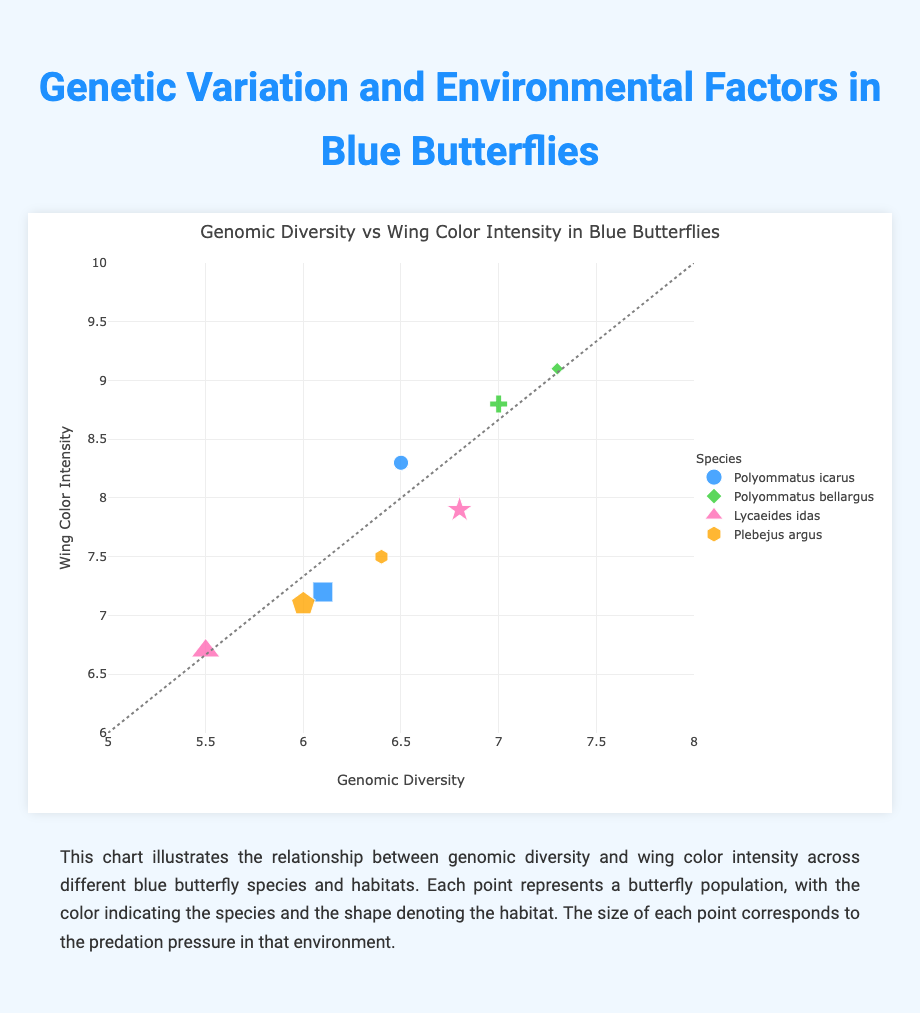What is the title of the chart? The title is located at the top of the chart and indicates what the data is about.
Answer: Genomic Diversity vs Wing Color Intensity in Blue Butterflies How many species of blue butterflies are represented in the chart? The legend on the right side of the chart lists the different species, each represented by a different color.
Answer: Four Which species shows the highest wing color intensity? By observing the y-axis (Wing Color Intensity) and correlating it with the species, the highest point corresponds to "Polyommatus bellargus".
Answer: Polyommatus bellargus Which habitat has a butterfly with the lowest genomic diversity? Check the x-axis (Genomic Diversity) to find the smallest value and then refer to the hover text or symbols to identify the corresponding habitat.
Answer: Boreal Forest Which species experiences the highest predation pressure? Look for the largest markers, as predation pressure is represented by the size of the points. The species' details can be verified by the legend.
Answer: Lycaeides idas What is the average wing color intensity of "Plebejus argus" butterflies? Find all points associated with "Plebejus argus", note their y-values (wing color intensity), sum them up, and divide by the number of points. The values are 7.5 and 7.1, so (7.5 + 7.1) / 2 = 7.3.
Answer: 7.3 Which habitat tends to have butterflies with higher genomic diversity: Grassland or Coastal Dunes? Look at the points associated with Grassland and Coastal Dunes. Compare their x-values (genomic diversity). Coastal Dunes generally have higher genomic diversity.
Answer: Coastal Dunes How is predation pressure visually represented on the chart? The description below the chart mentions that the size of each point corresponds to the predation pressure. Hence, larger points mean higher predation pressure.
Answer: By the size of the markers Among the species, which one shows the most variability in wing color intensity? Observe the spread of points on the y-axis for each species. The species with the widest range has the most variability. "Polyommatus icarus" shows a considerable spread from 7.2 to 8.3.
Answer: Polyommatus icarus Is there a clear correlation between genomic diversity and wing color intensity across the species? Draw a trendline or visually assess the line of best fit. The line provided in the chart isn't strictly diagonal, suggesting no clear correlation. Additionally, the variety of point positions illustrates a scattered distribution.
Answer: No clear correlation 